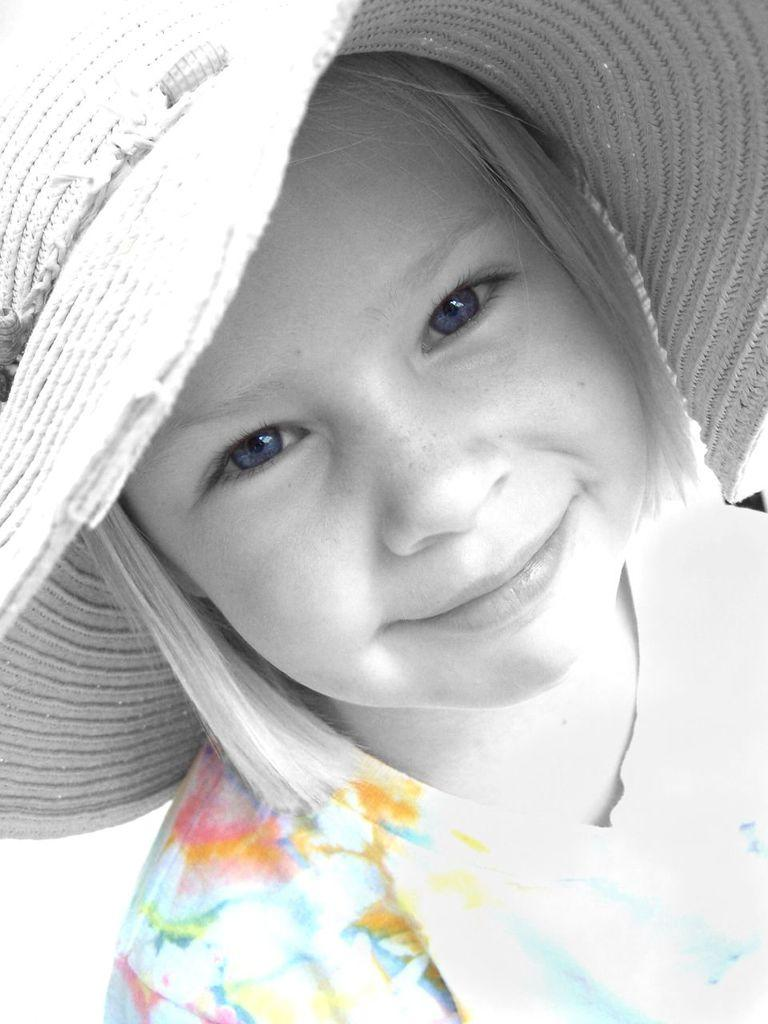Who is the main subject in the image? There is a girl in the image. What is the girl wearing on her head? The girl is wearing a hat. What type of nail is the girl using to fix the battle scene in the image? There is no nail or battle scene present in the image; it features a girl wearing a hat. How many pies can be seen on the table in the image? There are no pies or tables present in the image; it features a girl wearing a hat. 